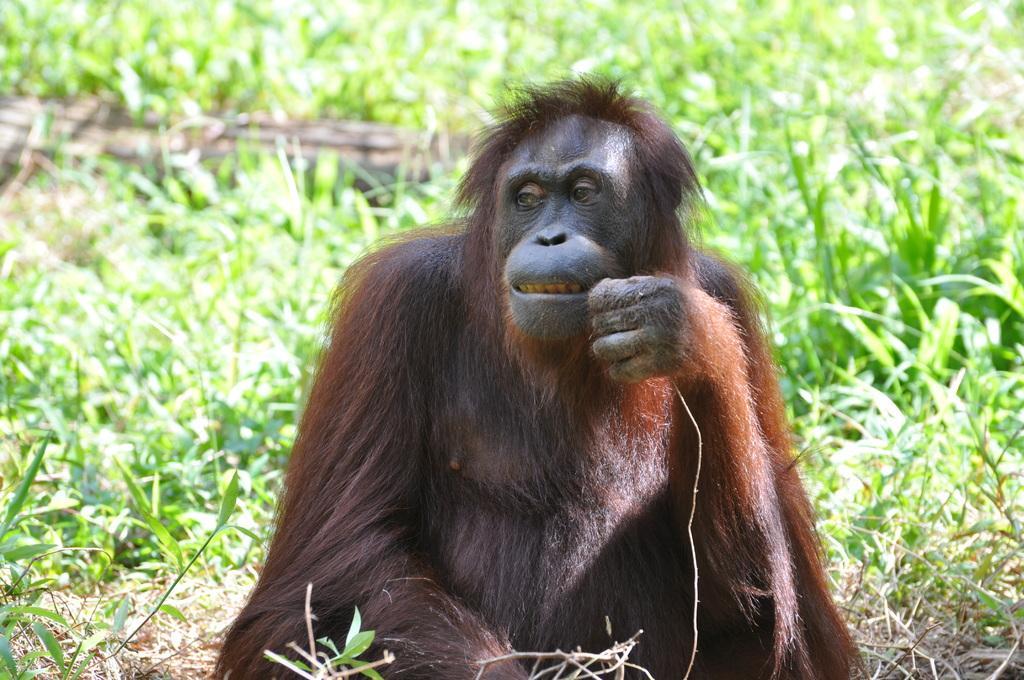In one or two sentences, can you explain what this image depicts? In the middle of this image, there is a black color chimpanzee, watching something and sitting. On the left side, there are plants. On the right side, there are plants. In the background, there are plants. And the background is blurred. 